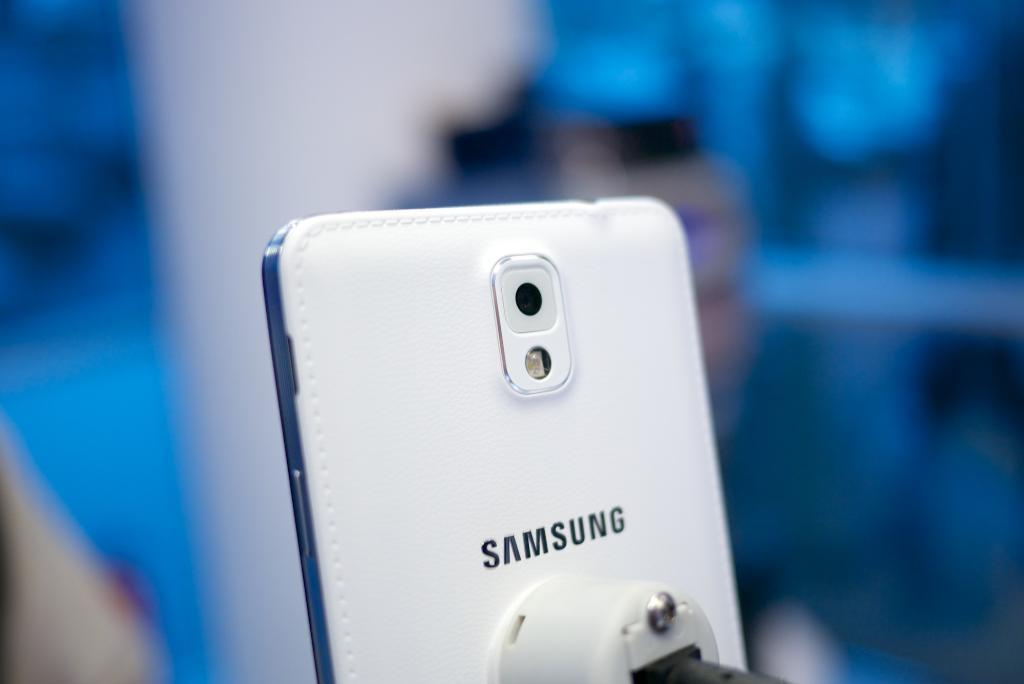What can be seen in the image? There is a mobile in the image. What else is visible in the image besides the mobile? There are objects in the background of the image. How would you describe the quality of the image? The image is blurry. What type of meal is the woman cooking in the image? There is no woman or cooking activity present in the image. 